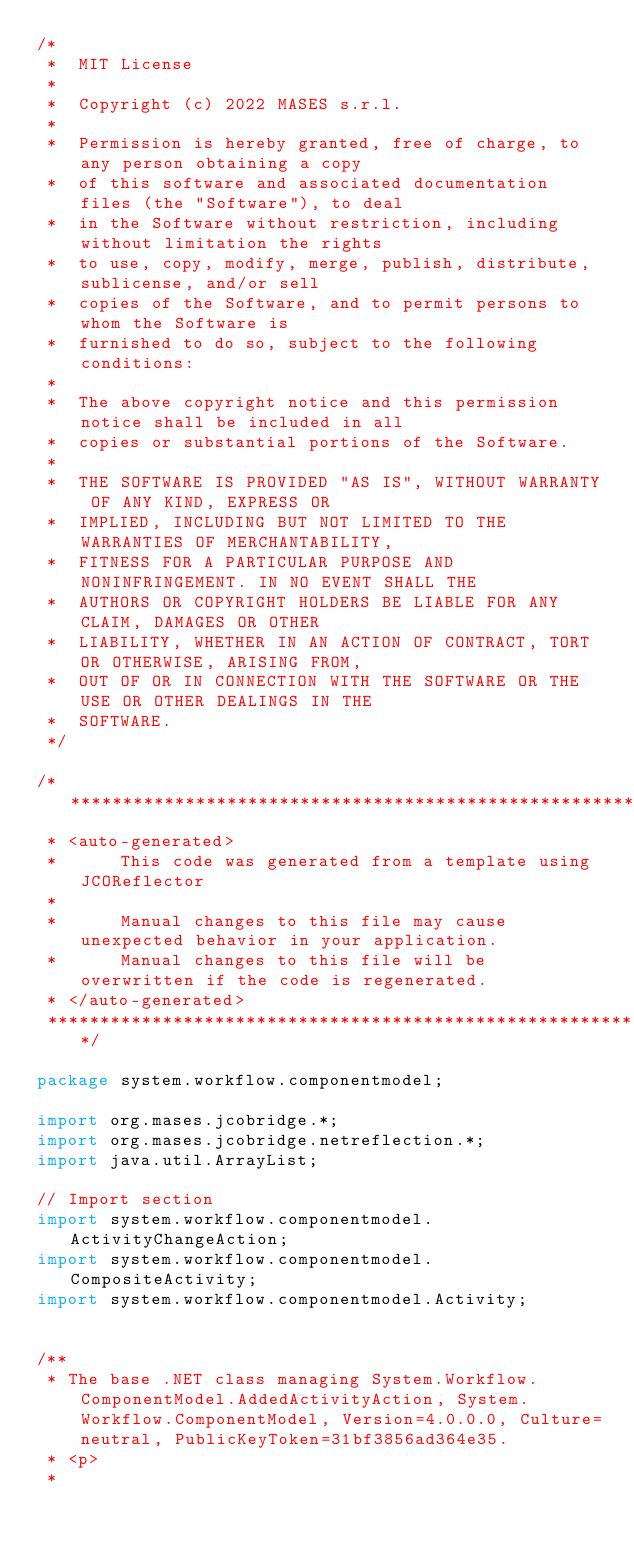<code> <loc_0><loc_0><loc_500><loc_500><_Java_>/*
 *  MIT License
 *
 *  Copyright (c) 2022 MASES s.r.l.
 *
 *  Permission is hereby granted, free of charge, to any person obtaining a copy
 *  of this software and associated documentation files (the "Software"), to deal
 *  in the Software without restriction, including without limitation the rights
 *  to use, copy, modify, merge, publish, distribute, sublicense, and/or sell
 *  copies of the Software, and to permit persons to whom the Software is
 *  furnished to do so, subject to the following conditions:
 *
 *  The above copyright notice and this permission notice shall be included in all
 *  copies or substantial portions of the Software.
 *
 *  THE SOFTWARE IS PROVIDED "AS IS", WITHOUT WARRANTY OF ANY KIND, EXPRESS OR
 *  IMPLIED, INCLUDING BUT NOT LIMITED TO THE WARRANTIES OF MERCHANTABILITY,
 *  FITNESS FOR A PARTICULAR PURPOSE AND NONINFRINGEMENT. IN NO EVENT SHALL THE
 *  AUTHORS OR COPYRIGHT HOLDERS BE LIABLE FOR ANY CLAIM, DAMAGES OR OTHER
 *  LIABILITY, WHETHER IN AN ACTION OF CONTRACT, TORT OR OTHERWISE, ARISING FROM,
 *  OUT OF OR IN CONNECTION WITH THE SOFTWARE OR THE USE OR OTHER DEALINGS IN THE
 *  SOFTWARE.
 */

/**************************************************************************************
 * <auto-generated>
 *      This code was generated from a template using JCOReflector
 * 
 *      Manual changes to this file may cause unexpected behavior in your application.
 *      Manual changes to this file will be overwritten if the code is regenerated.
 * </auto-generated>
 *************************************************************************************/

package system.workflow.componentmodel;

import org.mases.jcobridge.*;
import org.mases.jcobridge.netreflection.*;
import java.util.ArrayList;

// Import section
import system.workflow.componentmodel.ActivityChangeAction;
import system.workflow.componentmodel.CompositeActivity;
import system.workflow.componentmodel.Activity;


/**
 * The base .NET class managing System.Workflow.ComponentModel.AddedActivityAction, System.Workflow.ComponentModel, Version=4.0.0.0, Culture=neutral, PublicKeyToken=31bf3856ad364e35.
 * <p>
 * </code> 